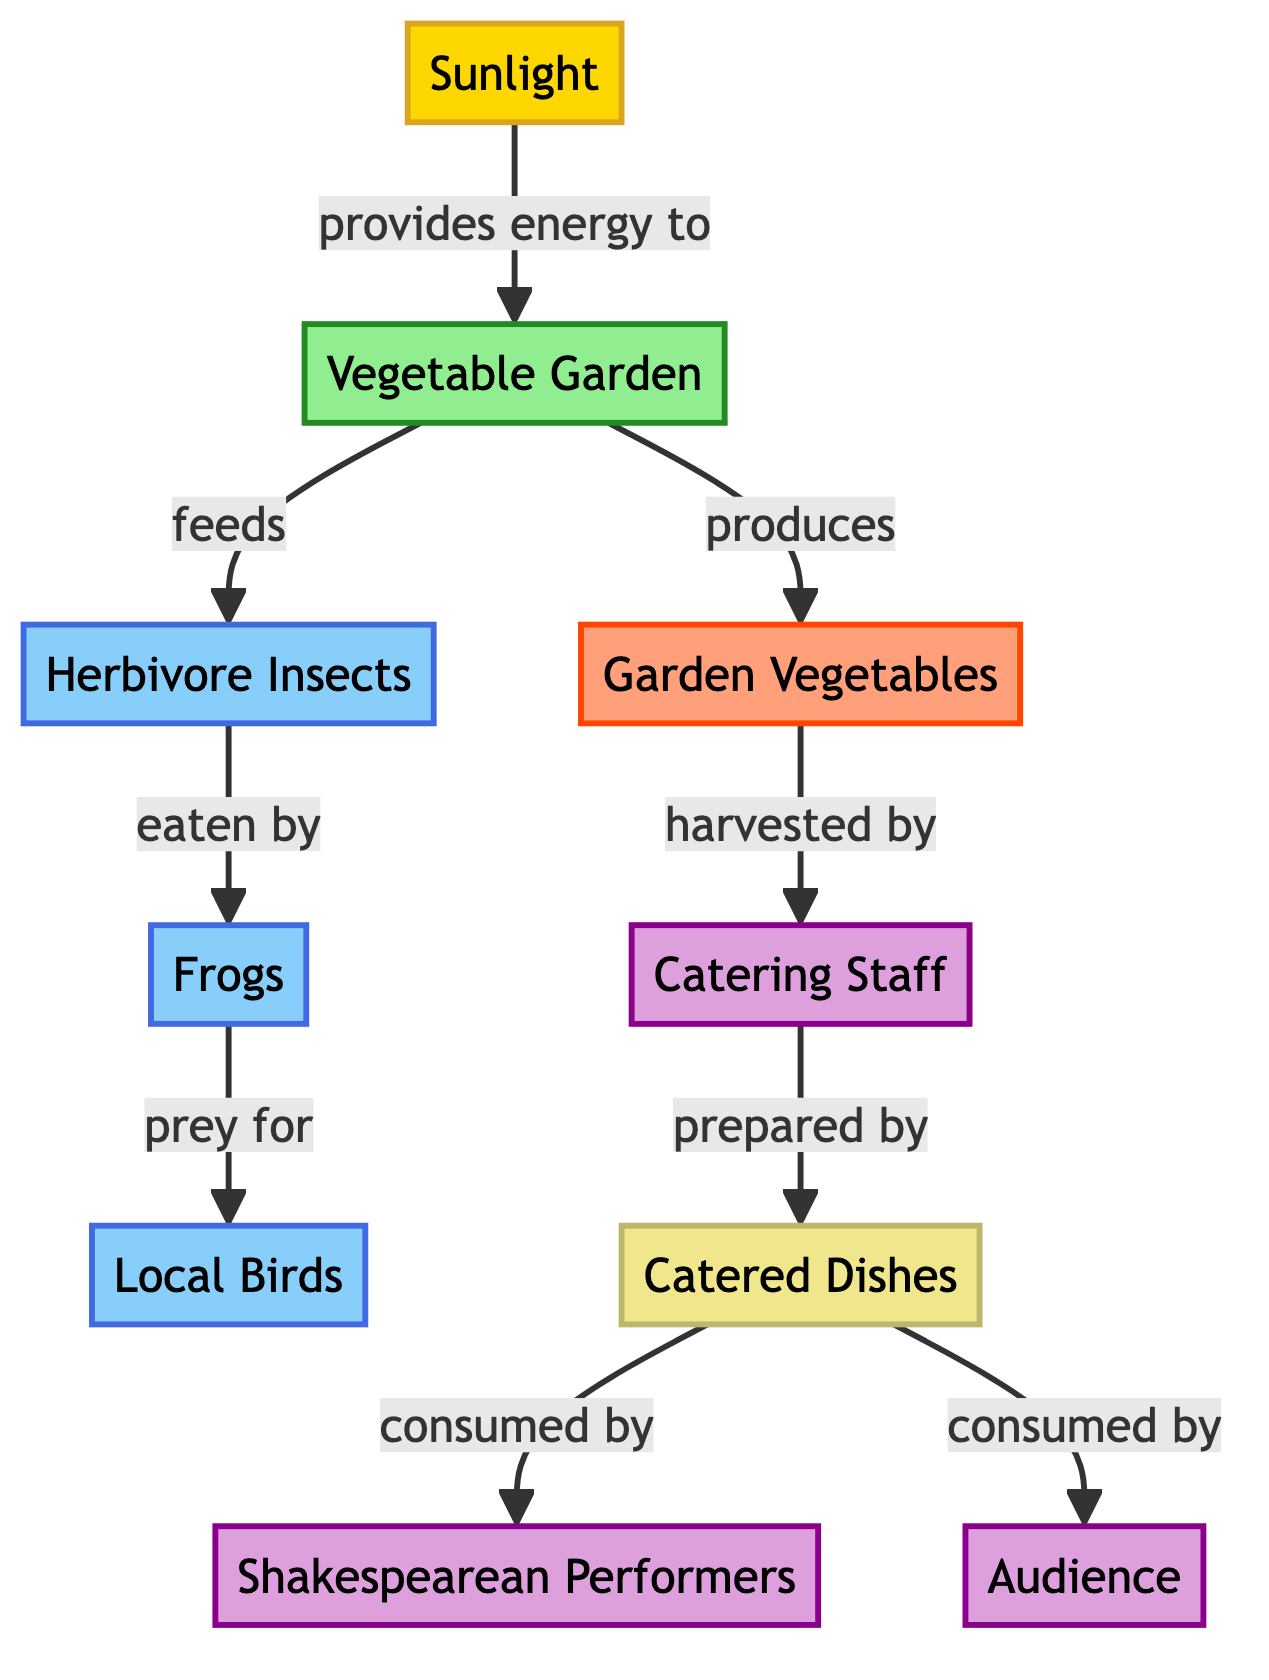What is the energy source in the food chain? The diagram clearly identifies "Sunlight" as the energy source, which is the first node of the food chain.
Answer: Sunlight How many different types of consumers are in the diagram? By reviewing the diagram, we can count that there are three consumer types: "Herbivore Insects," "Frogs," and "Local Birds." Thus, there are three distinct consumer nodes.
Answer: 3 What do "Garden Vegetables" produce according to the diagram? The "Garden Vegetables" node is indicated to be produced by the "Vegetable Garden," highlighting their role in the ecosystem as a product of the garden.
Answer: Garden Vegetables Who harvests the "Garden Vegetables"? According to the diagram, the "Catering Staff" node is directly connected to the "Garden Vegetables" node, which indicates that they are the ones who harvest these vegetables.
Answer: Catering Staff What is the final destination of the "Catered Dishes"? The diagram shows that "Catered Dishes" are consumed by both "Shakespearean Performers" and "Audience." Hence, the final entities interacting with the catered dishes are these two groups.
Answer: Shakespearean Performers and Audience What connects the "Frogs" and the "Local Birds"? The diagram depicts that "Frogs" are prey for "Local Birds," establishing a direct relationship between these two consumer types in the food chain.
Answer: Prey What is the role of "Catering Staff" in the food chain? "Catering Staff" are indicated to harvest the "Garden Vegetables" and then prepare them into "Catered Dishes," demonstrating their role as humans interacting directly with the food chain.
Answer: Harvest and Prepare Which node represents the final consumer in the diagram? The "Shakespearean Performers" and "Audience" are the nodes that consume food, making them the final consumers in the food chain depicted in this diagram.
Answer: Shakespearean Performers and Audience What is the relationship between "Sunlight" and "Vegetable Garden"? The diagram illustrates that "Sunlight" provides energy to the "Vegetable Garden," establishing a foundational relationship where energy from sunlight supports plant growth.
Answer: Provides energy to 